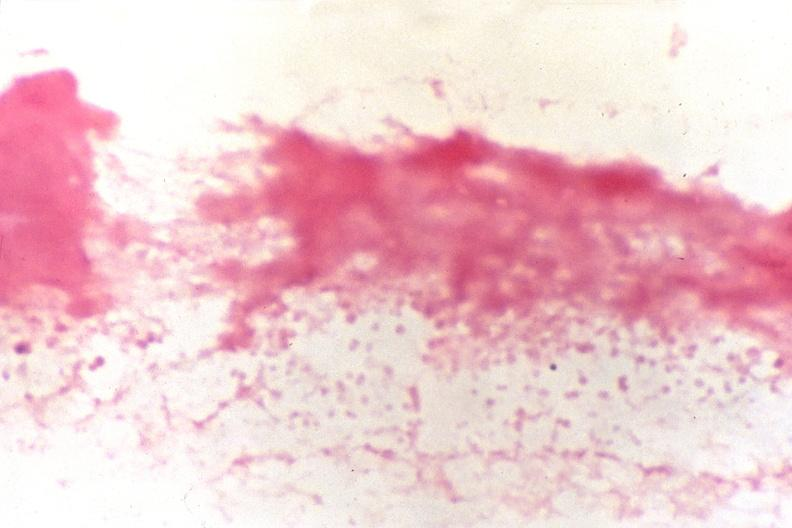does silver show cerebrospinal fluid, smear showing gram negative cocci, neisseria meningitidis, gram stain?
Answer the question using a single word or phrase. No 